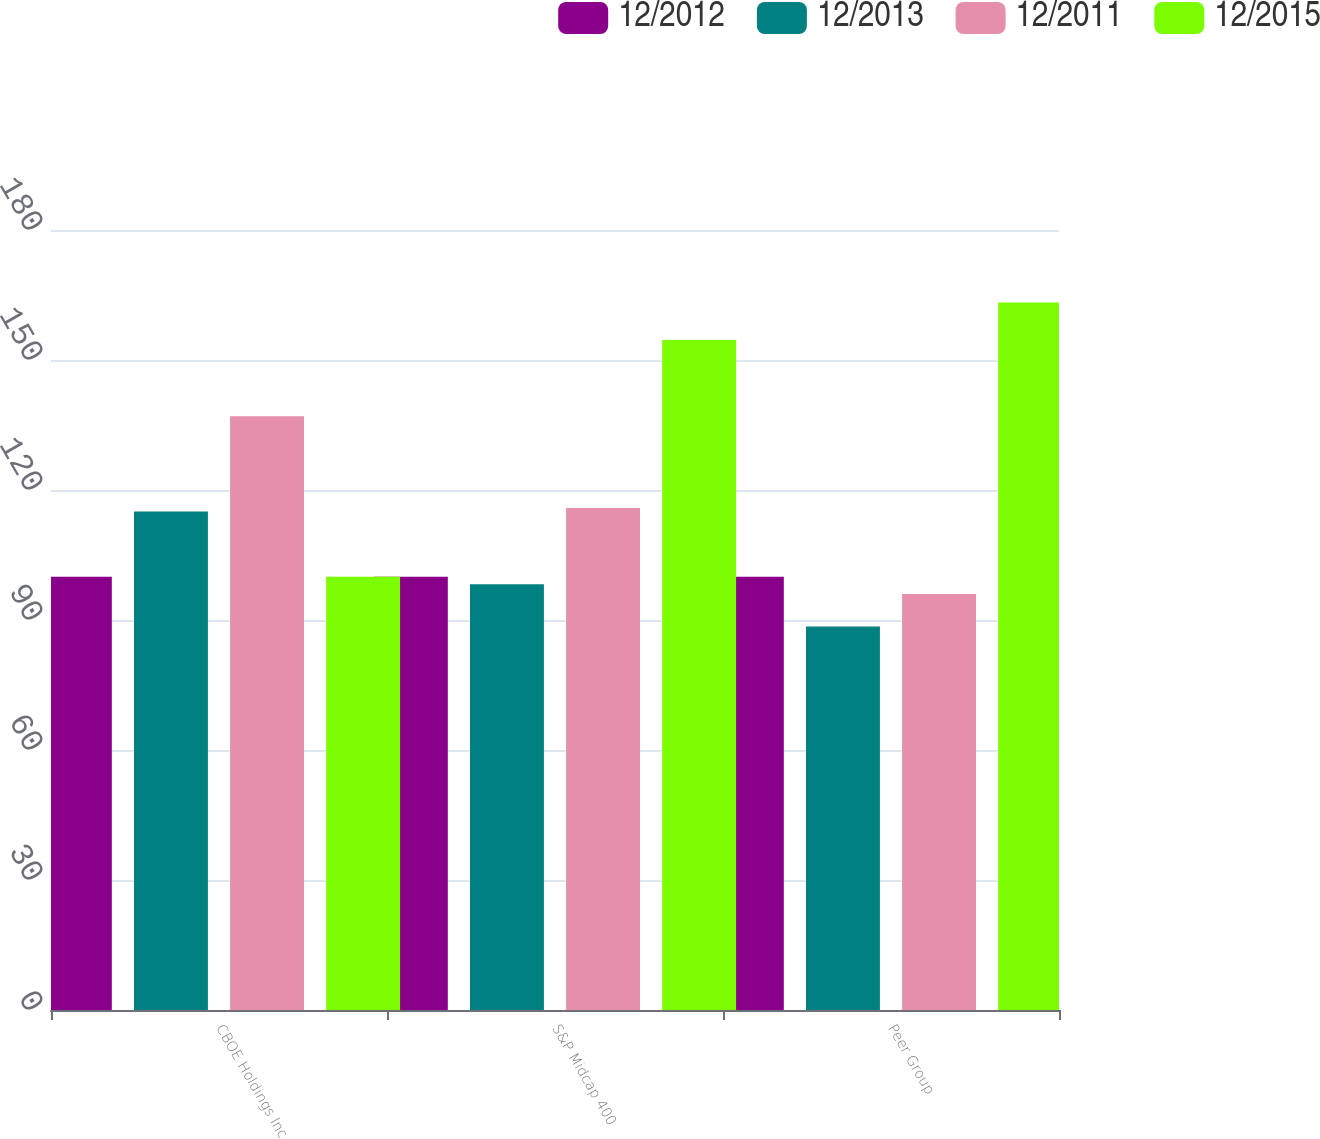<chart> <loc_0><loc_0><loc_500><loc_500><stacked_bar_chart><ecel><fcel>CBOE Holdings Inc<fcel>S&P Midcap 400<fcel>Peer Group<nl><fcel>12/2012<fcel>100<fcel>100<fcel>100<nl><fcel>12/2013<fcel>115.04<fcel>98.27<fcel>88.52<nl><fcel>12/2011<fcel>137.01<fcel>115.84<fcel>96.01<nl><fcel>12/2015<fcel>100<fcel>154.64<fcel>163.29<nl></chart> 